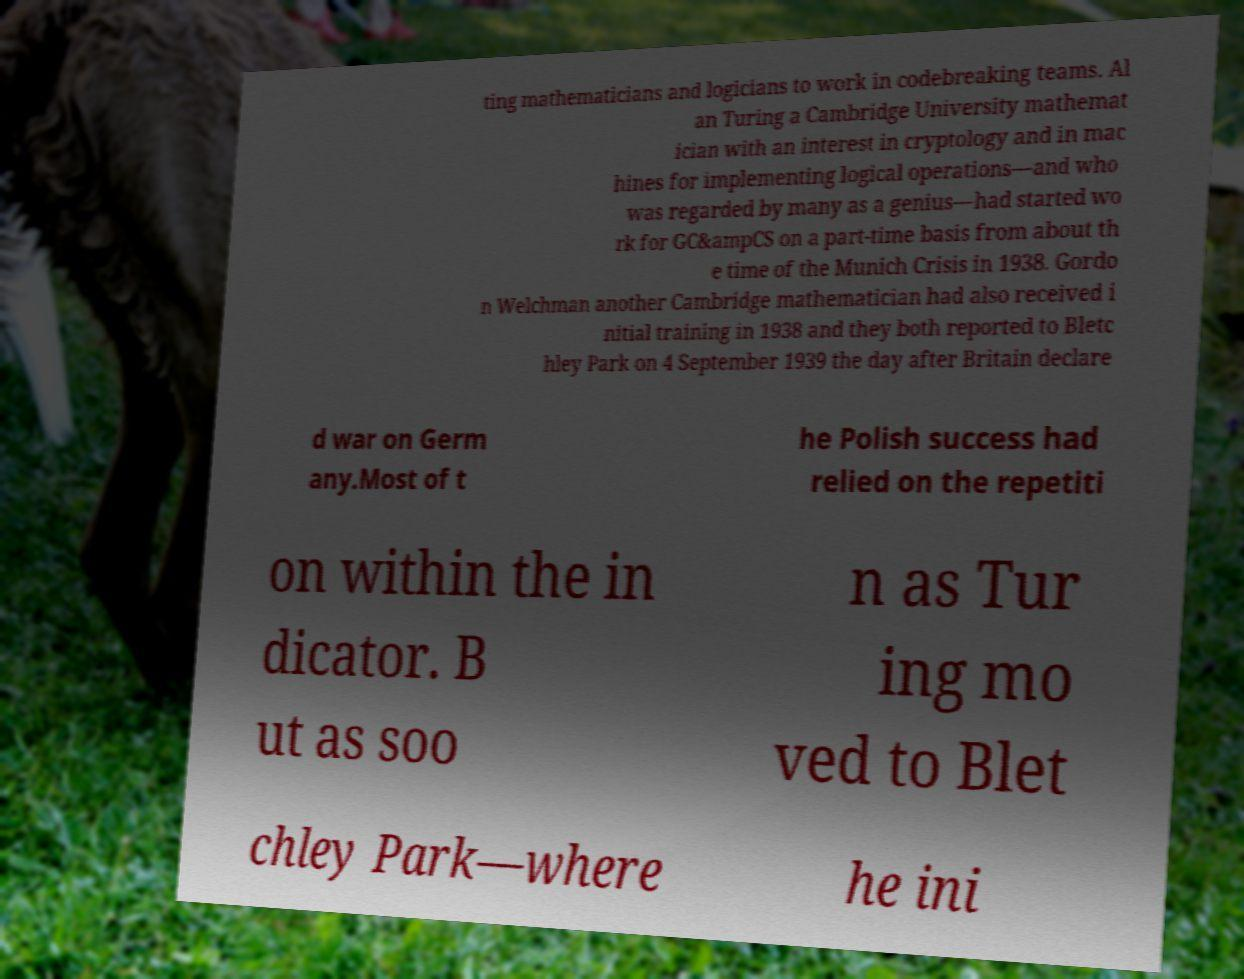I need the written content from this picture converted into text. Can you do that? ting mathematicians and logicians to work in codebreaking teams. Al an Turing a Cambridge University mathemat ician with an interest in cryptology and in mac hines for implementing logical operations—and who was regarded by many as a genius—had started wo rk for GC&ampCS on a part-time basis from about th e time of the Munich Crisis in 1938. Gordo n Welchman another Cambridge mathematician had also received i nitial training in 1938 and they both reported to Bletc hley Park on 4 September 1939 the day after Britain declare d war on Germ any.Most of t he Polish success had relied on the repetiti on within the in dicator. B ut as soo n as Tur ing mo ved to Blet chley Park—where he ini 